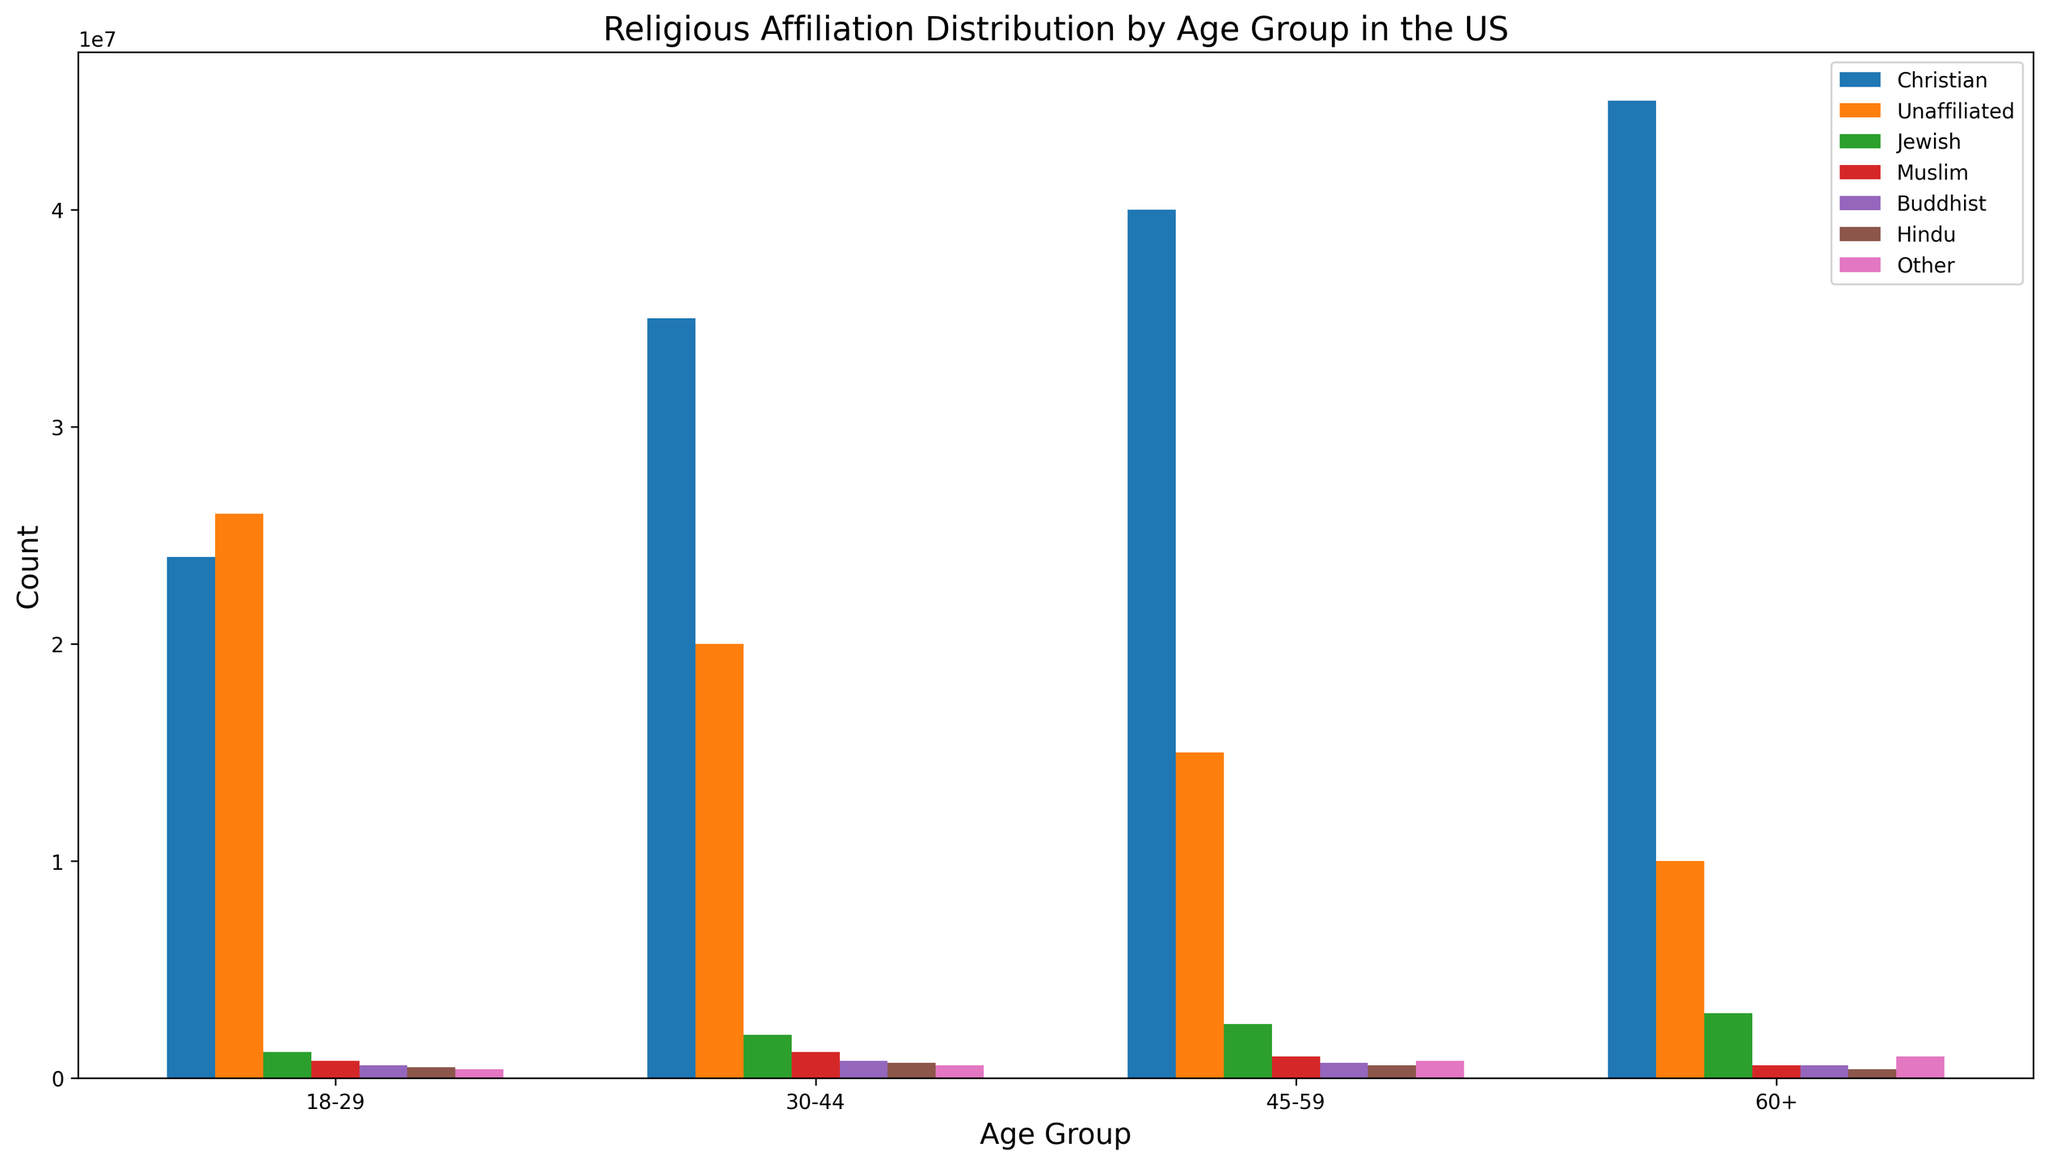Which age group has the highest count of Christians? To find the age group with the highest count of Christians, look for the tallest blue bar representing Christians across all age groups. The 60+ age group has the highest bar.
Answer: 60+ What is the difference in the number of Unaffiliated individuals between the 18-29 and 30-44 age groups? To find the difference, locate the bars for Unaffiliated individuals in both age groups and subtract the 30-44 value from the 18-29 value. The counts are 26,000,000 and 20,000,000 respectively. The difference is 26,000,000 - 20,000,000.
Answer: 6,000,000 Which religious affiliation has the lowest count in the 45-59 age group? To determine the affiliation with the lowest count, examine the bars in the 45-59 age group and find the shortest one. This corresponds to Buddhists with a count of 700,000.
Answer: Buddhist How does the count of Jewish individuals in the 60+ age group compare to the 18-29 age group? Compare the height of the bars for Jewish individuals in both age groups. In the 60+ age group, the count is 3,000,000, while in the 18-29 age group, the count is 1,200,000. Therefore, the 60+ age group has a higher count.
Answer: 60+ has a higher count What is the total count of Hindu individuals across all age groups? Sum the counts of Hindu individuals from all age groups: 500,000 (18-29) + 700,000 (30-44) + 600,000 (45-59) + 400,000 (60+). The total count is 500,000 + 700,000 + 600,000 + 400,000.
Answer: 2,200,000 Which age group has the most balanced distribution of religious affiliations? Evaluate the bars within each age group to see which one appears the most even across all affiliations. The 45-59 age group appears to have a relatively balanced distribution since the differences in bar heights are less pronounced compared to other age groups.
Answer: 45-59 What percentage of individuals in the 18-29 age group are Christians? To find the percentage, divide the count of Christians by the total count for the 18-29 age group and then multiply by 100. Total count for 18-29 = 24,000,000 (Christian) + 26,000,000 (Unaffiliated) + 1,200,000 (Jewish) + 800,000 (Muslim) + 600,000 (Buddhist) + 500,000 (Hindu) + 400,000 (Other) = 53,500,000. So, (24,000,000 / 53,500,000) * 100 ≈ 44.86%.
Answer: 44.86% What is the count of the largest non-Christian religious group in the 30-44 age group, and which affiliation is it? Identify the tallest bar among the non-Christian affiliations in the 30-44 age group. The largest count is for the Unaffiliated group with a count of 20,000,000.
Answer: 20,000,000, Unaffiliated What is the overall trend seen in the count of Christian individuals as age increases? Observe the height of the bars representing Christians across increasing age groups. The counts clearly increase progressively from 18-29 to 60+ age group.
Answer: Increasing trend 